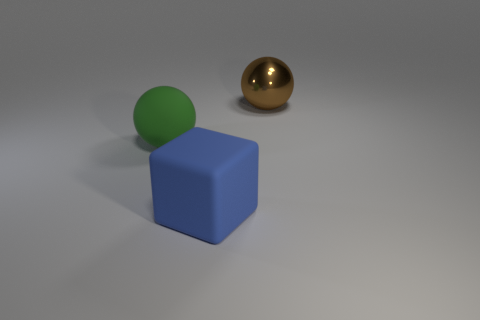Does the large object left of the large rubber cube have the same shape as the large shiny thing?
Provide a short and direct response. Yes. Is there any other thing that is the same material as the big brown sphere?
Your answer should be very brief. No. There is a block; is its size the same as the ball that is behind the large green thing?
Provide a short and direct response. Yes. How many other objects are there of the same color as the large rubber cube?
Your response must be concise. 0. Are there any big blue matte objects to the right of the green matte sphere?
Keep it short and to the point. Yes. How many objects are either blocks or objects behind the blue cube?
Ensure brevity in your answer.  3. Are there any large green rubber spheres that are in front of the big sphere in front of the brown thing?
Your answer should be very brief. No. There is a rubber object that is right of the large ball in front of the object that is on the right side of the blue matte block; what is its shape?
Give a very brief answer. Cube. There is a object that is behind the blue object and right of the green object; what is its color?
Give a very brief answer. Brown. There is a large thing that is behind the green matte object; what is its shape?
Ensure brevity in your answer.  Sphere. 